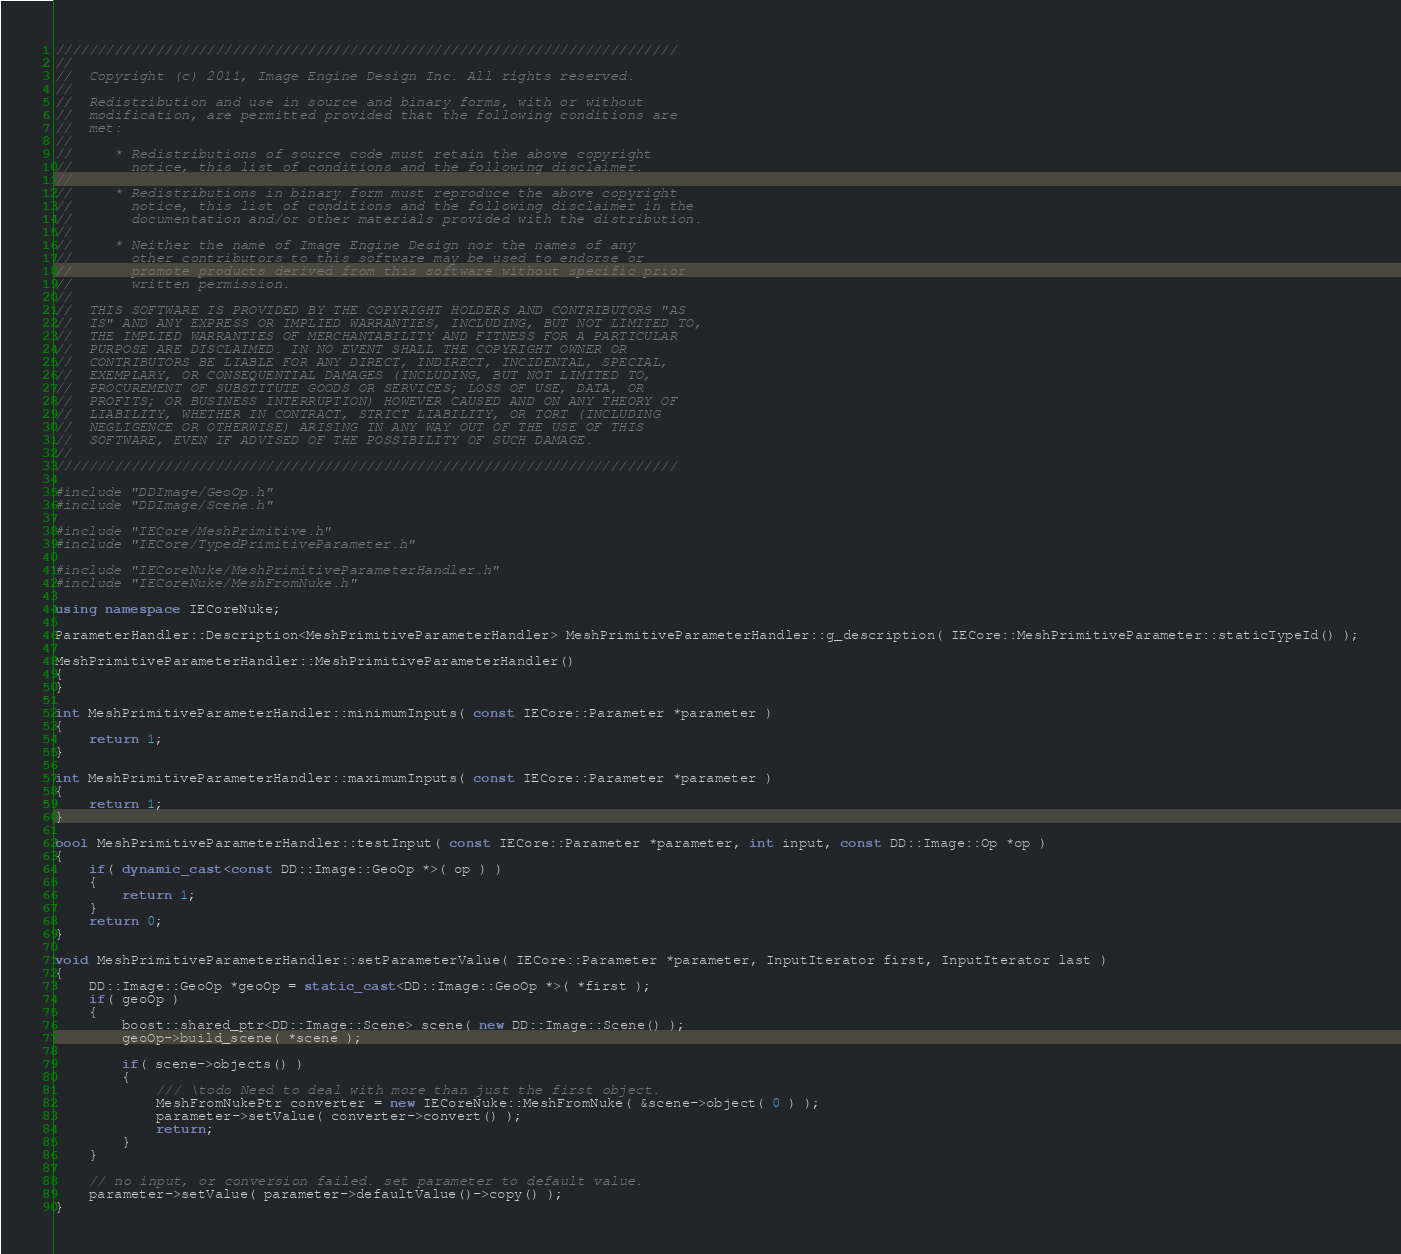<code> <loc_0><loc_0><loc_500><loc_500><_C++_>//////////////////////////////////////////////////////////////////////////
//
//  Copyright (c) 2011, Image Engine Design Inc. All rights reserved.
//
//  Redistribution and use in source and binary forms, with or without
//  modification, are permitted provided that the following conditions are
//  met:
//
//     * Redistributions of source code must retain the above copyright
//       notice, this list of conditions and the following disclaimer.
//
//     * Redistributions in binary form must reproduce the above copyright
//       notice, this list of conditions and the following disclaimer in the
//       documentation and/or other materials provided with the distribution.
//
//     * Neither the name of Image Engine Design nor the names of any
//       other contributors to this software may be used to endorse or
//       promote products derived from this software without specific prior
//       written permission.
//
//  THIS SOFTWARE IS PROVIDED BY THE COPYRIGHT HOLDERS AND CONTRIBUTORS "AS
//  IS" AND ANY EXPRESS OR IMPLIED WARRANTIES, INCLUDING, BUT NOT LIMITED TO,
//  THE IMPLIED WARRANTIES OF MERCHANTABILITY AND FITNESS FOR A PARTICULAR
//  PURPOSE ARE DISCLAIMED. IN NO EVENT SHALL THE COPYRIGHT OWNER OR
//  CONTRIBUTORS BE LIABLE FOR ANY DIRECT, INDIRECT, INCIDENTAL, SPECIAL,
//  EXEMPLARY, OR CONSEQUENTIAL DAMAGES (INCLUDING, BUT NOT LIMITED TO,
//  PROCUREMENT OF SUBSTITUTE GOODS OR SERVICES; LOSS OF USE, DATA, OR
//  PROFITS; OR BUSINESS INTERRUPTION) HOWEVER CAUSED AND ON ANY THEORY OF
//  LIABILITY, WHETHER IN CONTRACT, STRICT LIABILITY, OR TORT (INCLUDING
//  NEGLIGENCE OR OTHERWISE) ARISING IN ANY WAY OUT OF THE USE OF THIS
//  SOFTWARE, EVEN IF ADVISED OF THE POSSIBILITY OF SUCH DAMAGE.
//
//////////////////////////////////////////////////////////////////////////

#include "DDImage/GeoOp.h"
#include "DDImage/Scene.h"

#include "IECore/MeshPrimitive.h"
#include "IECore/TypedPrimitiveParameter.h"

#include "IECoreNuke/MeshPrimitiveParameterHandler.h"
#include "IECoreNuke/MeshFromNuke.h"

using namespace IECoreNuke;

ParameterHandler::Description<MeshPrimitiveParameterHandler> MeshPrimitiveParameterHandler::g_description( IECore::MeshPrimitiveParameter::staticTypeId() );

MeshPrimitiveParameterHandler::MeshPrimitiveParameterHandler()
{
}
		
int MeshPrimitiveParameterHandler::minimumInputs( const IECore::Parameter *parameter )
{
	return 1;
}

int MeshPrimitiveParameterHandler::maximumInputs( const IECore::Parameter *parameter )
{
	return 1;
}

bool MeshPrimitiveParameterHandler::testInput( const IECore::Parameter *parameter, int input, const DD::Image::Op *op )
{
	if( dynamic_cast<const DD::Image::GeoOp *>( op ) )
	{
		return 1;
	}
	return 0;
}

void MeshPrimitiveParameterHandler::setParameterValue( IECore::Parameter *parameter, InputIterator first, InputIterator last )
{
	DD::Image::GeoOp *geoOp = static_cast<DD::Image::GeoOp *>( *first );
	if( geoOp )
	{
		boost::shared_ptr<DD::Image::Scene> scene( new DD::Image::Scene() );
		geoOp->build_scene( *scene );

		if( scene->objects() )
		{
			/// \todo Need to deal with more than just the first object.
			MeshFromNukePtr converter = new IECoreNuke::MeshFromNuke( &scene->object( 0 ) );
			parameter->setValue( converter->convert() );
			return;
		}
	}
	
	// no input, or conversion failed. set parameter to default value.
	parameter->setValue( parameter->defaultValue()->copy() );
}
</code> 